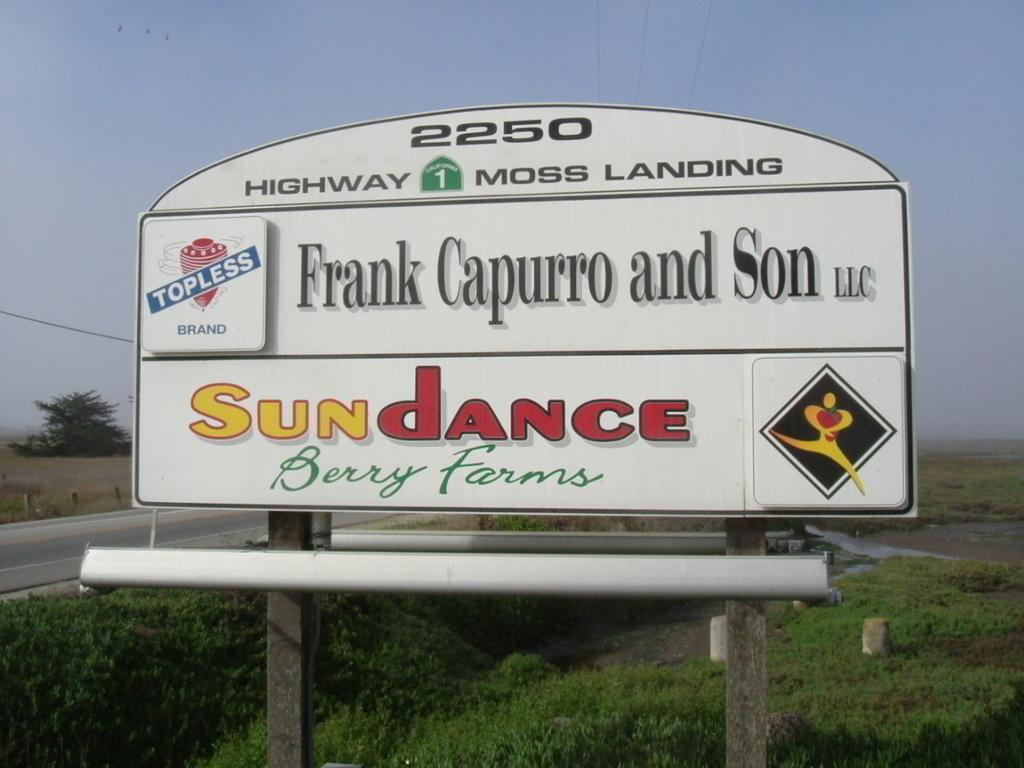What is the main object in the center of the image? There is a name board in the center of the image. What can be seen in the background of the image? Water, grass, trees, and the sky are visible in the background of the image. What is the size of the copper used in the name board? There is no copper mentioned in the image, and the name board's size cannot be determined from the provided facts. 